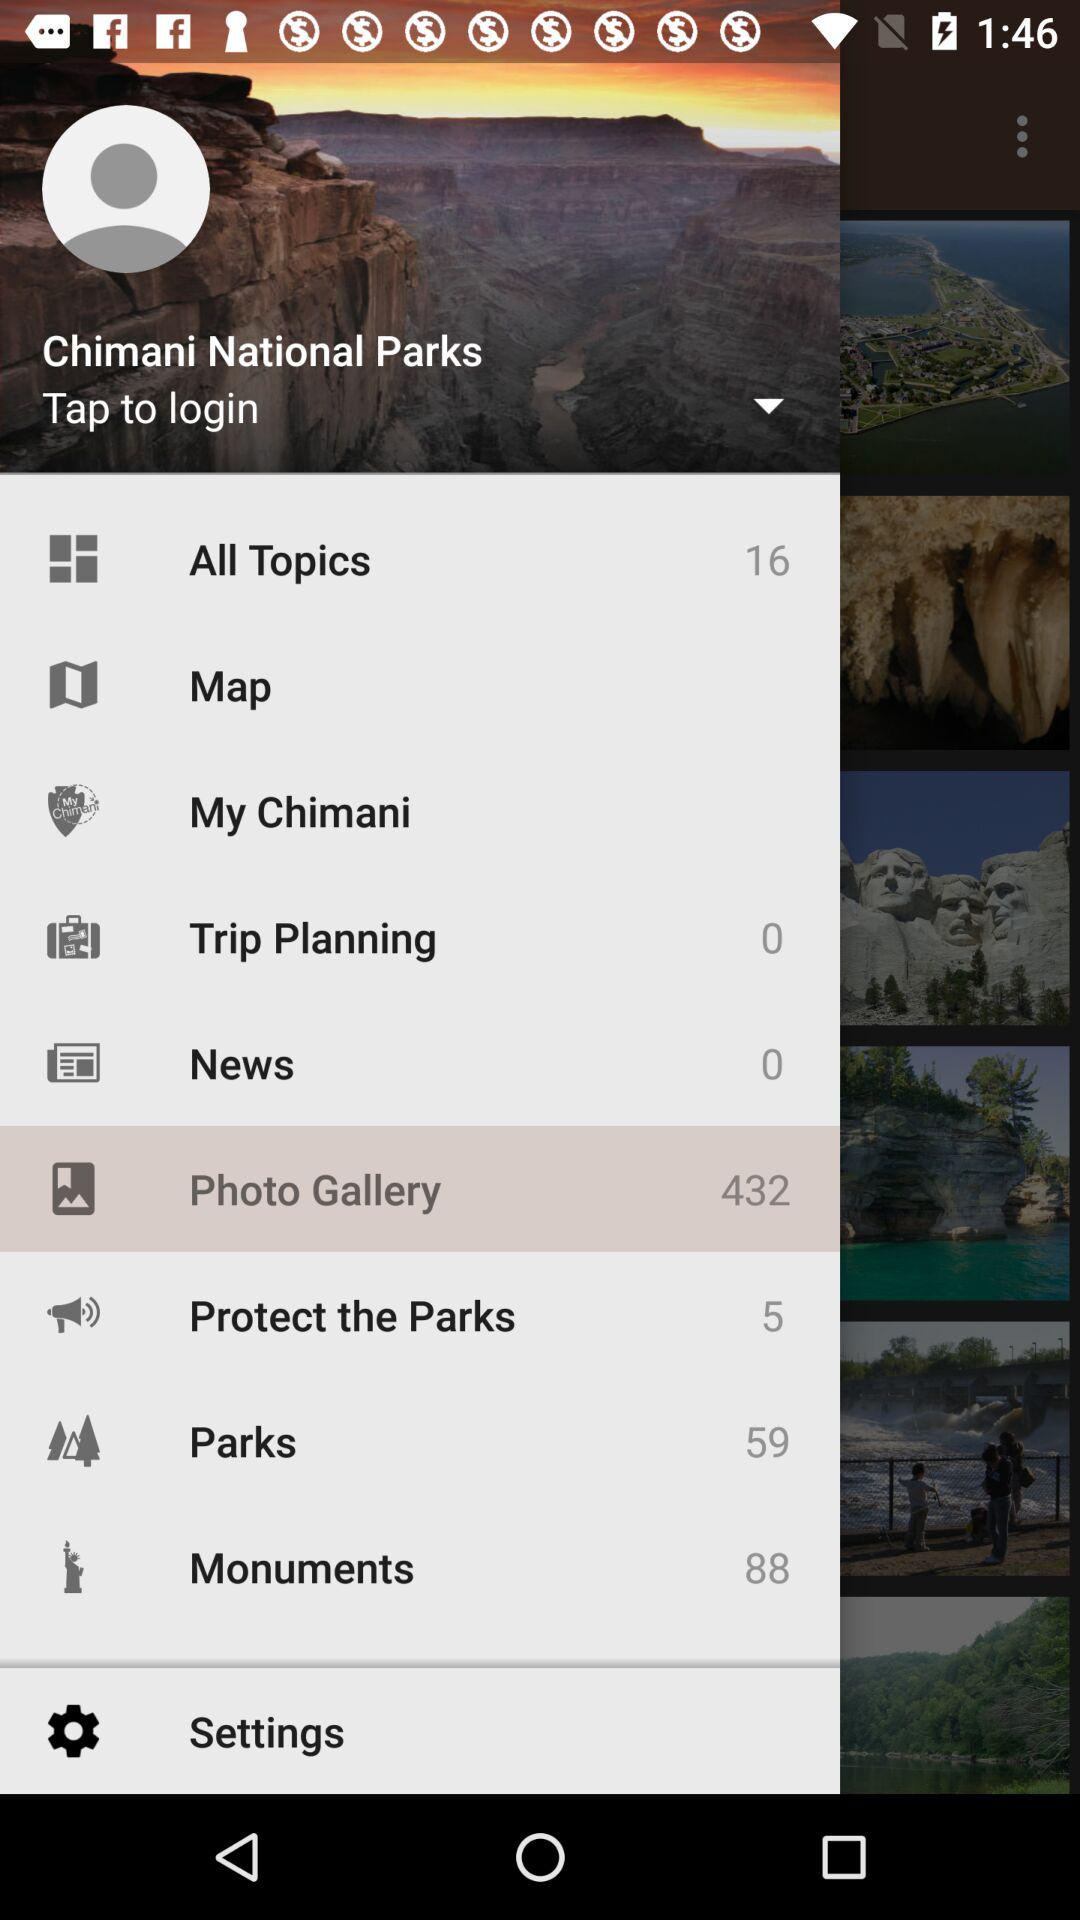How many monuments in total are there? There are 88 monuments in total. 